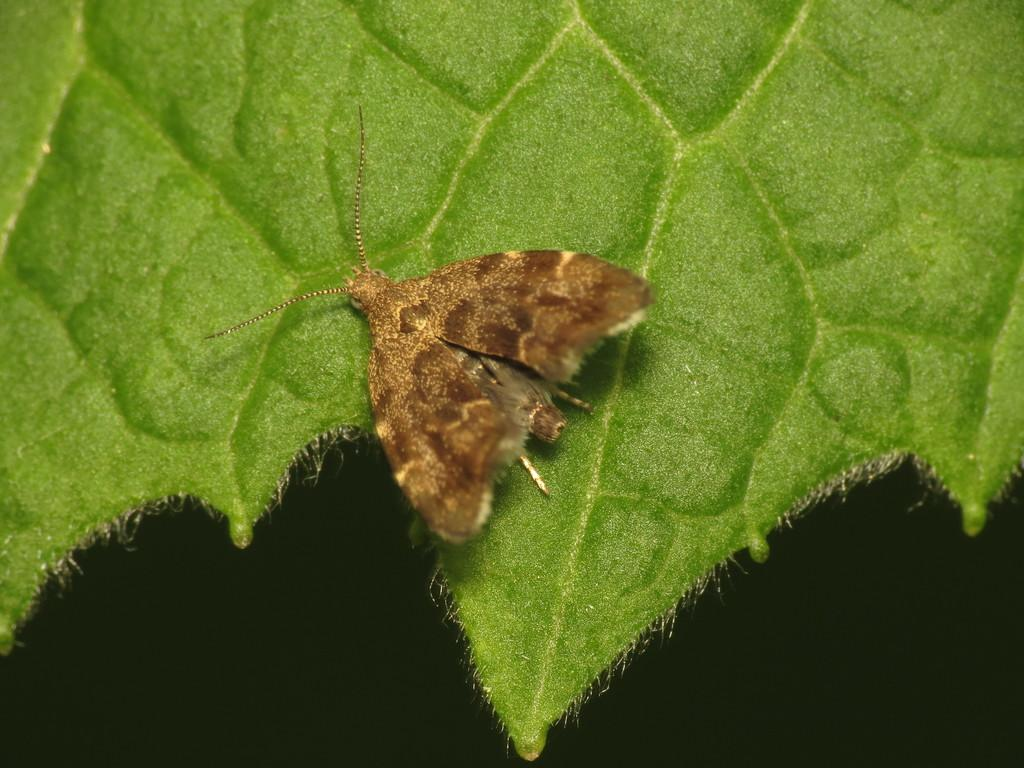What is the main subject of the image? The main subject of the image is a leaf. Is there anything on the leaf? Yes, there is a butterfly on the leaf. What can be observed about the background of the image? The background of the image is dark. What type of comfort does the parent provide to the child in the image? There is no child or parent present in the image; it features a leaf with a butterfly on it. 